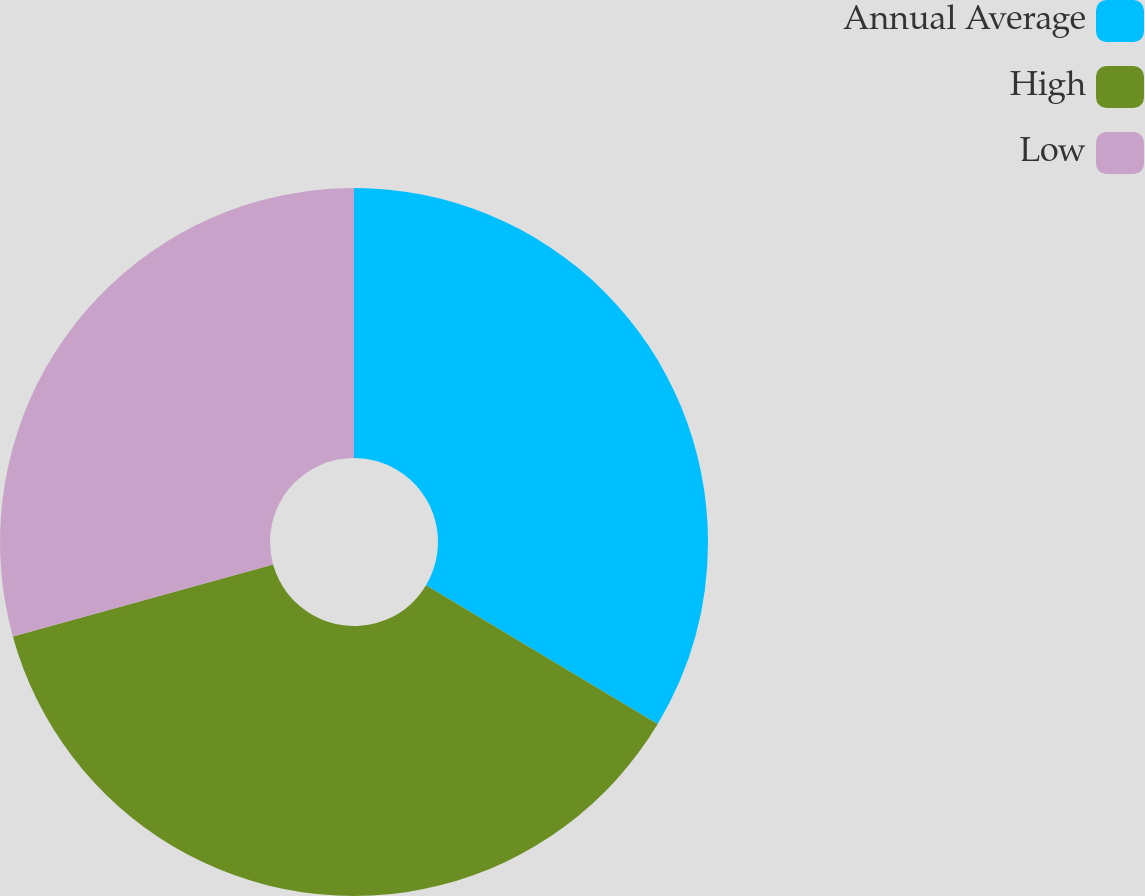Convert chart to OTSL. <chart><loc_0><loc_0><loc_500><loc_500><pie_chart><fcel>Annual Average<fcel>High<fcel>Low<nl><fcel>33.59%<fcel>37.11%<fcel>29.3%<nl></chart> 